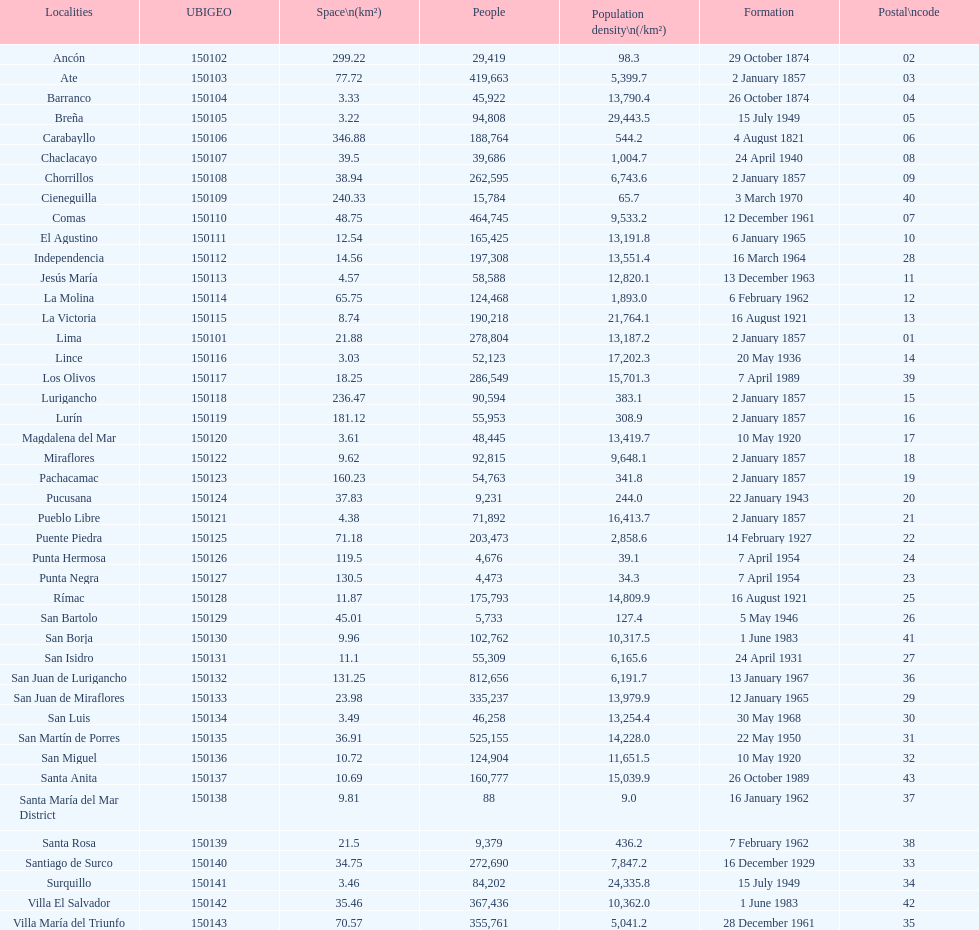When was the final district established? Santa Anita. 